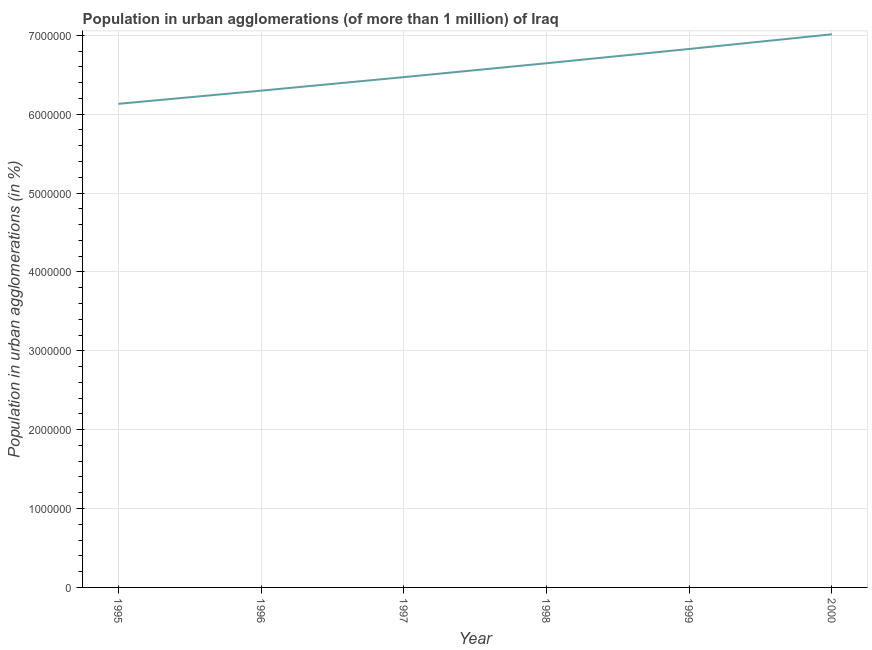What is the population in urban agglomerations in 1995?
Your answer should be very brief. 6.13e+06. Across all years, what is the maximum population in urban agglomerations?
Your answer should be very brief. 7.01e+06. Across all years, what is the minimum population in urban agglomerations?
Offer a very short reply. 6.13e+06. In which year was the population in urban agglomerations maximum?
Offer a terse response. 2000. In which year was the population in urban agglomerations minimum?
Provide a short and direct response. 1995. What is the sum of the population in urban agglomerations?
Offer a very short reply. 3.94e+07. What is the difference between the population in urban agglomerations in 1995 and 1997?
Your answer should be very brief. -3.38e+05. What is the average population in urban agglomerations per year?
Provide a succinct answer. 6.56e+06. What is the median population in urban agglomerations?
Give a very brief answer. 6.56e+06. In how many years, is the population in urban agglomerations greater than 3800000 %?
Your response must be concise. 6. What is the ratio of the population in urban agglomerations in 1998 to that in 2000?
Your answer should be compact. 0.95. Is the difference between the population in urban agglomerations in 1998 and 1999 greater than the difference between any two years?
Provide a succinct answer. No. What is the difference between the highest and the second highest population in urban agglomerations?
Offer a very short reply. 1.86e+05. Is the sum of the population in urban agglomerations in 1998 and 1999 greater than the maximum population in urban agglomerations across all years?
Your answer should be very brief. Yes. What is the difference between the highest and the lowest population in urban agglomerations?
Provide a short and direct response. 8.81e+05. In how many years, is the population in urban agglomerations greater than the average population in urban agglomerations taken over all years?
Keep it short and to the point. 3. Does the population in urban agglomerations monotonically increase over the years?
Offer a very short reply. Yes. How many years are there in the graph?
Offer a terse response. 6. Are the values on the major ticks of Y-axis written in scientific E-notation?
Provide a short and direct response. No. Does the graph contain any zero values?
Offer a very short reply. No. Does the graph contain grids?
Your answer should be compact. Yes. What is the title of the graph?
Your answer should be compact. Population in urban agglomerations (of more than 1 million) of Iraq. What is the label or title of the X-axis?
Your answer should be compact. Year. What is the label or title of the Y-axis?
Keep it short and to the point. Population in urban agglomerations (in %). What is the Population in urban agglomerations (in %) of 1995?
Ensure brevity in your answer.  6.13e+06. What is the Population in urban agglomerations (in %) of 1996?
Provide a succinct answer. 6.30e+06. What is the Population in urban agglomerations (in %) of 1997?
Offer a very short reply. 6.47e+06. What is the Population in urban agglomerations (in %) of 1998?
Keep it short and to the point. 6.65e+06. What is the Population in urban agglomerations (in %) of 1999?
Provide a short and direct response. 6.83e+06. What is the Population in urban agglomerations (in %) in 2000?
Give a very brief answer. 7.01e+06. What is the difference between the Population in urban agglomerations (in %) in 1995 and 1996?
Provide a succinct answer. -1.67e+05. What is the difference between the Population in urban agglomerations (in %) in 1995 and 1997?
Your answer should be very brief. -3.38e+05. What is the difference between the Population in urban agglomerations (in %) in 1995 and 1998?
Offer a terse response. -5.15e+05. What is the difference between the Population in urban agglomerations (in %) in 1995 and 1999?
Your answer should be very brief. -6.95e+05. What is the difference between the Population in urban agglomerations (in %) in 1995 and 2000?
Your answer should be compact. -8.81e+05. What is the difference between the Population in urban agglomerations (in %) in 1996 and 1997?
Give a very brief answer. -1.71e+05. What is the difference between the Population in urban agglomerations (in %) in 1996 and 1998?
Offer a very short reply. -3.47e+05. What is the difference between the Population in urban agglomerations (in %) in 1996 and 1999?
Your answer should be compact. -5.28e+05. What is the difference between the Population in urban agglomerations (in %) in 1996 and 2000?
Provide a succinct answer. -7.14e+05. What is the difference between the Population in urban agglomerations (in %) in 1997 and 1998?
Keep it short and to the point. -1.76e+05. What is the difference between the Population in urban agglomerations (in %) in 1997 and 1999?
Provide a short and direct response. -3.57e+05. What is the difference between the Population in urban agglomerations (in %) in 1997 and 2000?
Keep it short and to the point. -5.43e+05. What is the difference between the Population in urban agglomerations (in %) in 1998 and 1999?
Offer a terse response. -1.81e+05. What is the difference between the Population in urban agglomerations (in %) in 1998 and 2000?
Your answer should be compact. -3.67e+05. What is the difference between the Population in urban agglomerations (in %) in 1999 and 2000?
Your answer should be compact. -1.86e+05. What is the ratio of the Population in urban agglomerations (in %) in 1995 to that in 1996?
Keep it short and to the point. 0.97. What is the ratio of the Population in urban agglomerations (in %) in 1995 to that in 1997?
Your answer should be compact. 0.95. What is the ratio of the Population in urban agglomerations (in %) in 1995 to that in 1998?
Offer a very short reply. 0.92. What is the ratio of the Population in urban agglomerations (in %) in 1995 to that in 1999?
Give a very brief answer. 0.9. What is the ratio of the Population in urban agglomerations (in %) in 1995 to that in 2000?
Keep it short and to the point. 0.87. What is the ratio of the Population in urban agglomerations (in %) in 1996 to that in 1998?
Offer a very short reply. 0.95. What is the ratio of the Population in urban agglomerations (in %) in 1996 to that in 1999?
Provide a succinct answer. 0.92. What is the ratio of the Population in urban agglomerations (in %) in 1996 to that in 2000?
Ensure brevity in your answer.  0.9. What is the ratio of the Population in urban agglomerations (in %) in 1997 to that in 1999?
Your answer should be very brief. 0.95. What is the ratio of the Population in urban agglomerations (in %) in 1997 to that in 2000?
Provide a succinct answer. 0.92. What is the ratio of the Population in urban agglomerations (in %) in 1998 to that in 1999?
Make the answer very short. 0.97. What is the ratio of the Population in urban agglomerations (in %) in 1998 to that in 2000?
Your response must be concise. 0.95. 